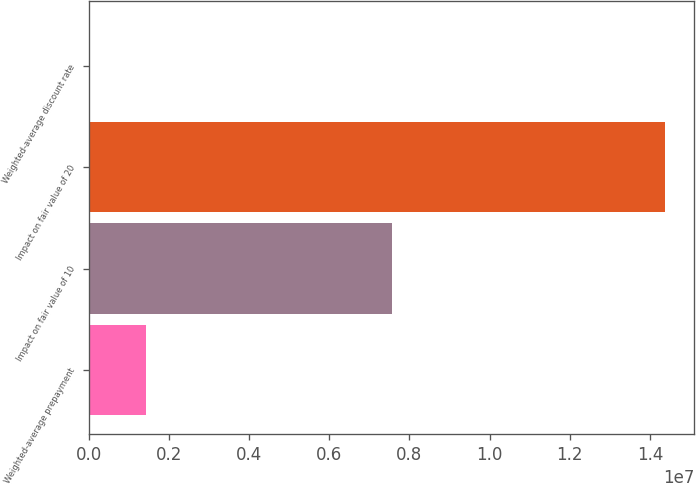<chart> <loc_0><loc_0><loc_500><loc_500><bar_chart><fcel>Weighted-average prepayment<fcel>Impact on fair value of 10<fcel>Impact on fair value of 20<fcel>Weighted-average discount rate<nl><fcel>1.43851e+06<fcel>7.574e+06<fcel>1.4385e+07<fcel>9.6<nl></chart> 